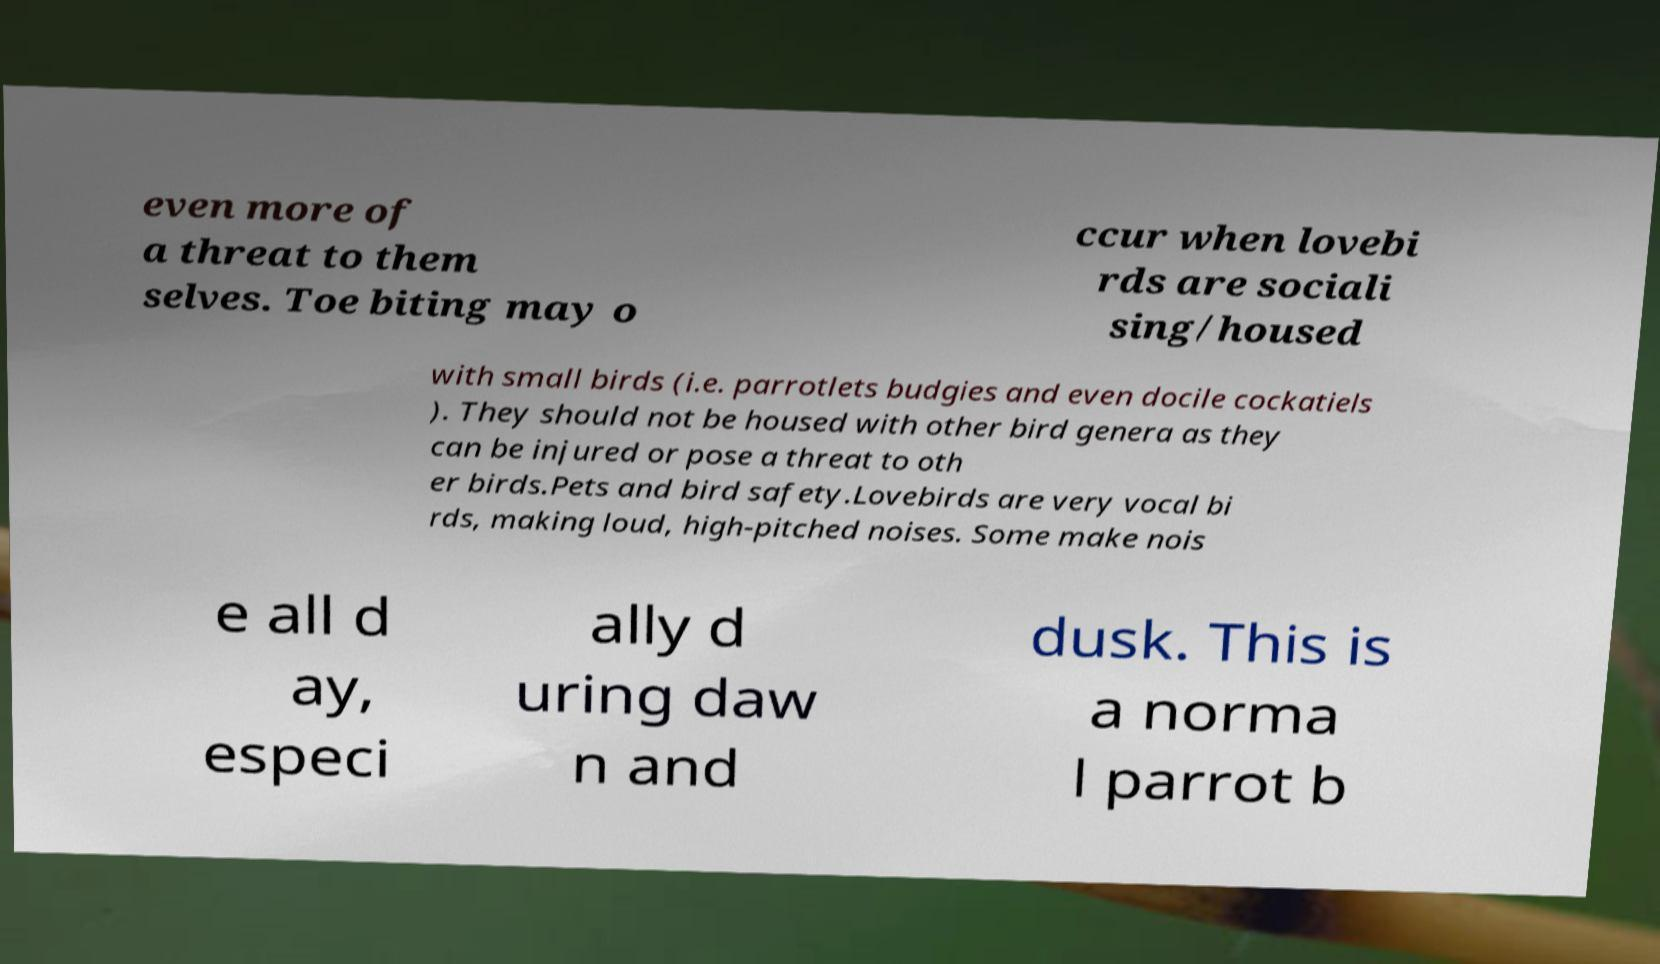Could you assist in decoding the text presented in this image and type it out clearly? even more of a threat to them selves. Toe biting may o ccur when lovebi rds are sociali sing/housed with small birds (i.e. parrotlets budgies and even docile cockatiels ). They should not be housed with other bird genera as they can be injured or pose a threat to oth er birds.Pets and bird safety.Lovebirds are very vocal bi rds, making loud, high-pitched noises. Some make nois e all d ay, especi ally d uring daw n and dusk. This is a norma l parrot b 